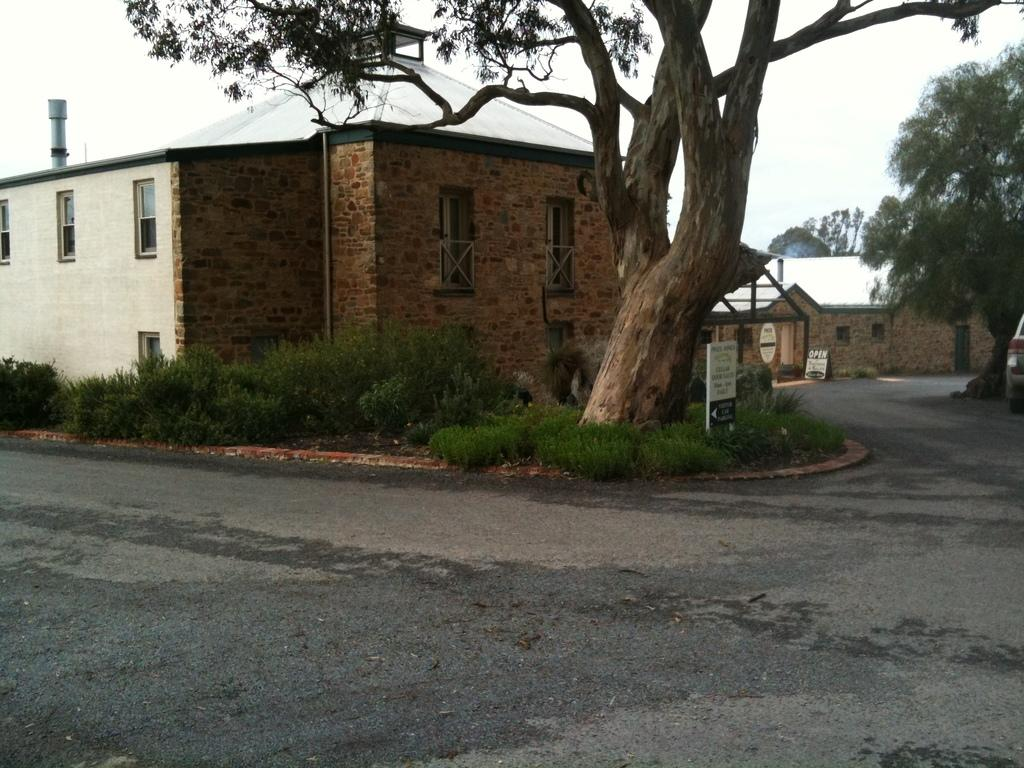What is: What is located in the front of the image? There is a road in the front of the image. Can you describe the house in the image? The house in the image has a brown and white color shade. What can be seen in the image besides the road and the house? There is a huge tree in the image. What is the queen doing in the image? There is no queen present in the image. What is the elbow of the tree in the image? There is no mention of an elbow in the image, as trees do not have elbows. 